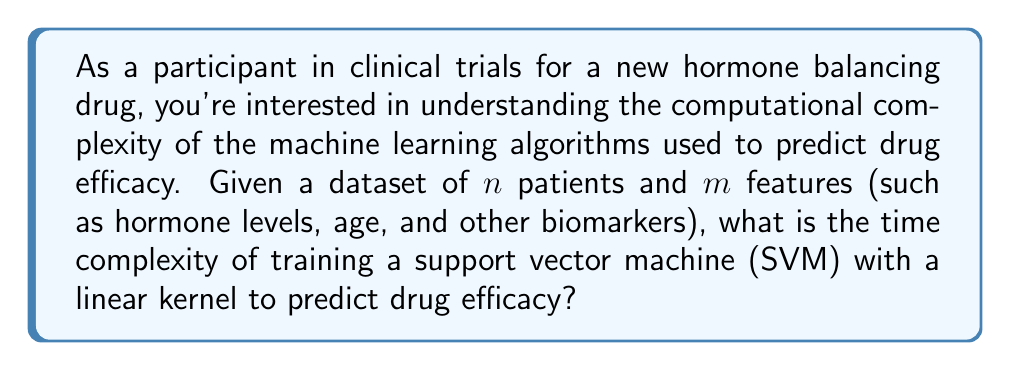Solve this math problem. To analyze the computational complexity of training a linear SVM, we need to consider the following steps:

1. The standard algorithm for training a linear SVM is the Sequential Minimal Optimization (SMO) algorithm.

2. The SMO algorithm iteratively optimizes pairs of Lagrange multipliers until convergence.

3. In the worst case, the number of iterations can be proportional to the number of training examples, $n$.

4. Each iteration involves:
   a. Selecting a pair of examples to optimize
   b. Computing the kernel function between these examples and all other examples
   c. Updating the model parameters

5. For a linear kernel, computing the kernel function between two examples takes $O(m)$ time, where $m$ is the number of features.

6. In each iteration, we need to compute the kernel function for $O(n)$ pairs of examples.

7. Therefore, each iteration has a time complexity of $O(nm)$.

8. Since there can be up to $n$ iterations in the worst case, the overall time complexity is $O(n^2m)$.

It's important to note that this is a worst-case analysis. In practice, the algorithm often converges much faster, especially with optimized implementations and heuristics for selecting example pairs.

For your specific case as a clinical trial participant, $n$ would represent the number of participants in the trial, and $m$ would represent the number of measured biomarkers and other relevant features for each participant.
Answer: The time complexity of training a linear SVM for predicting drug efficacy is $O(n^2m)$, where $n$ is the number of patients and $m$ is the number of features. 